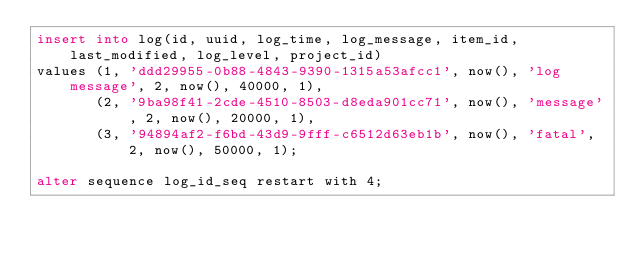<code> <loc_0><loc_0><loc_500><loc_500><_SQL_>insert into log(id, uuid, log_time, log_message, item_id, last_modified, log_level, project_id)
values (1, 'ddd29955-0b88-4843-9390-1315a53afcc1', now(), 'log message', 2, now(), 40000, 1),
       (2, '9ba98f41-2cde-4510-8503-d8eda901cc71', now(), 'message', 2, now(), 20000, 1),
       (3, '94894af2-f6bd-43d9-9fff-c6512d63eb1b', now(), 'fatal', 2, now(), 50000, 1);

alter sequence log_id_seq restart with 4;</code> 